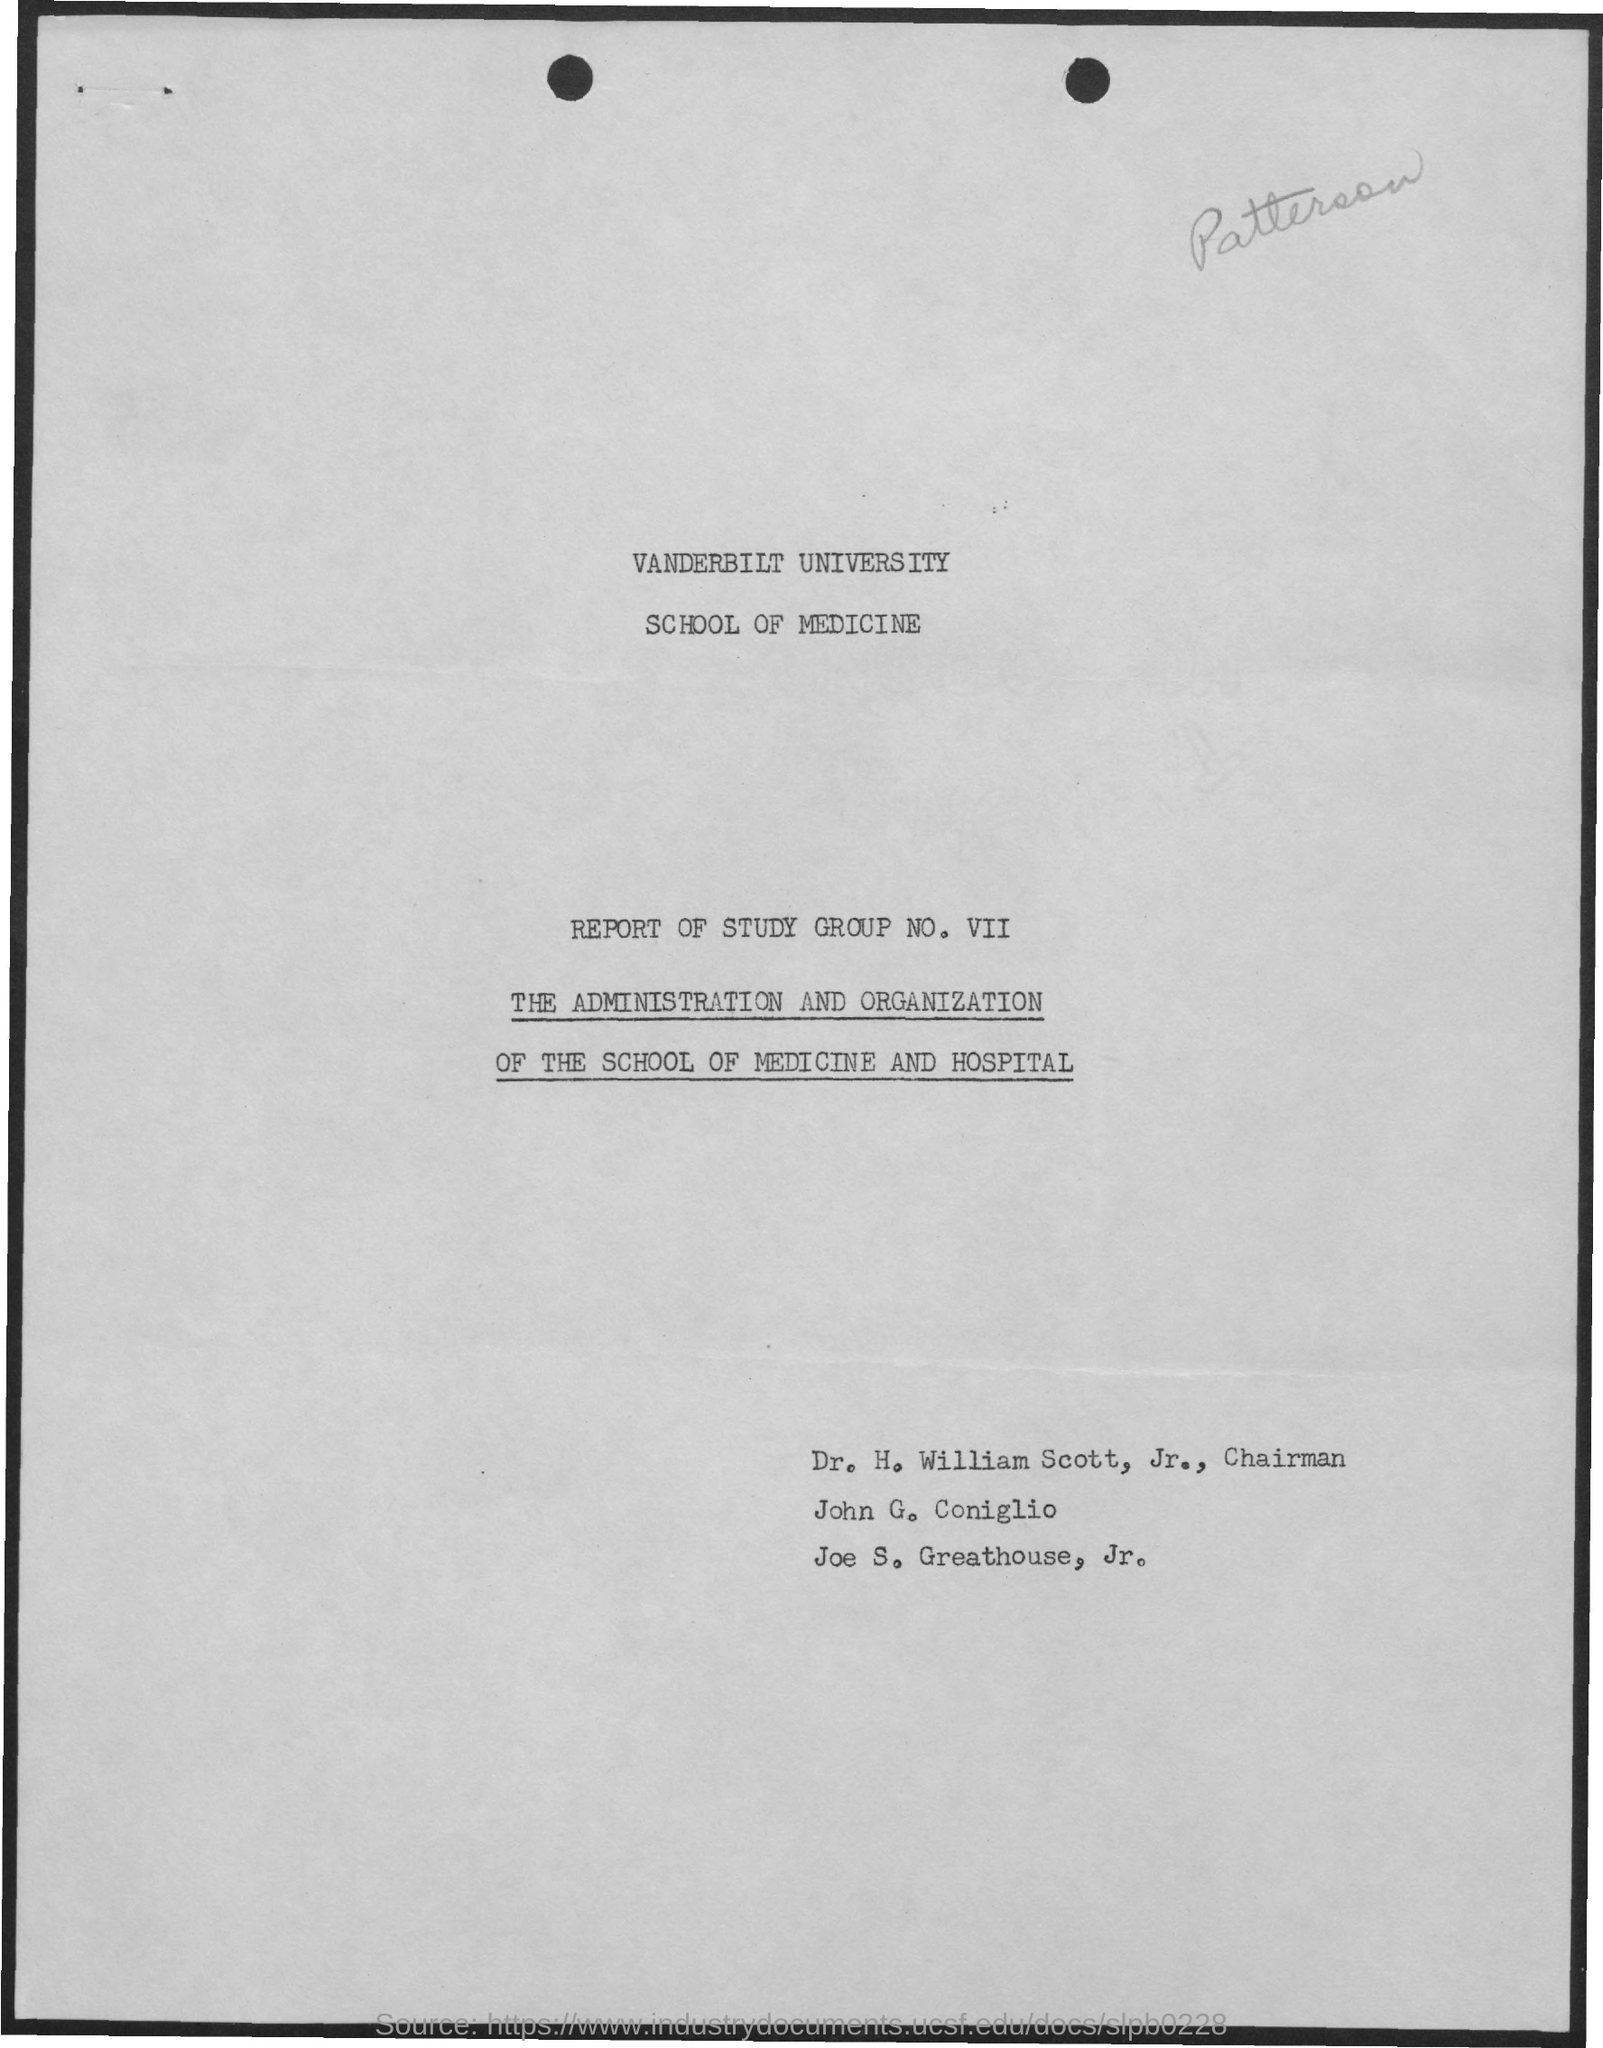Indicate a few pertinent items in this graphic. The group number mentioned is VII. 